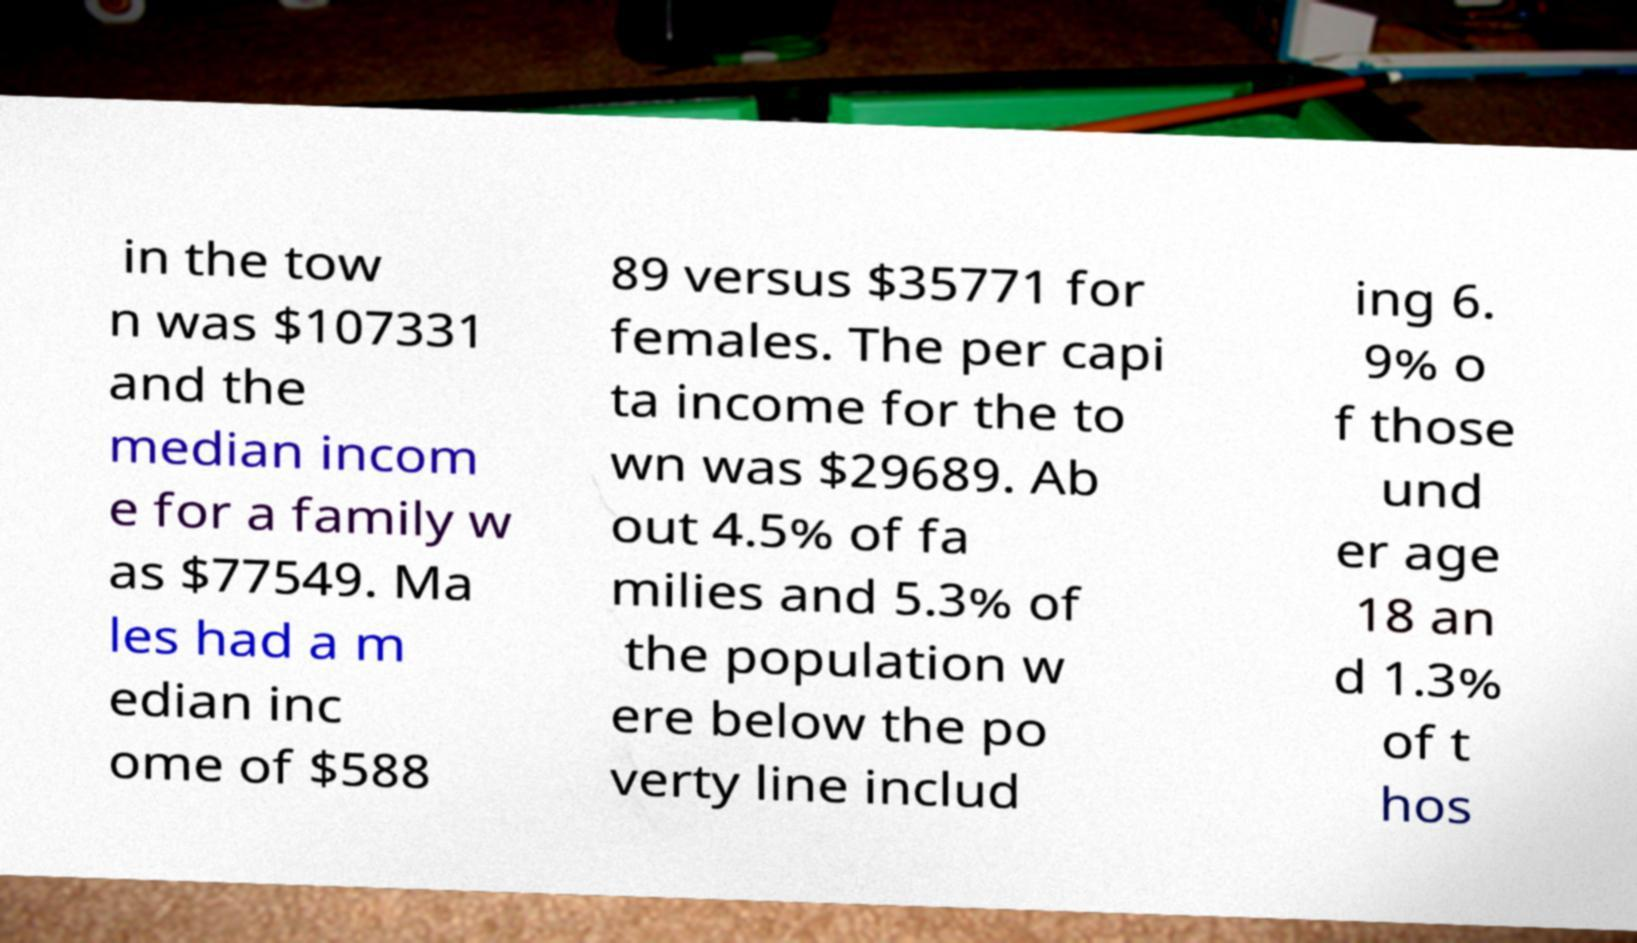Could you extract and type out the text from this image? in the tow n was $107331 and the median incom e for a family w as $77549. Ma les had a m edian inc ome of $588 89 versus $35771 for females. The per capi ta income for the to wn was $29689. Ab out 4.5% of fa milies and 5.3% of the population w ere below the po verty line includ ing 6. 9% o f those und er age 18 an d 1.3% of t hos 